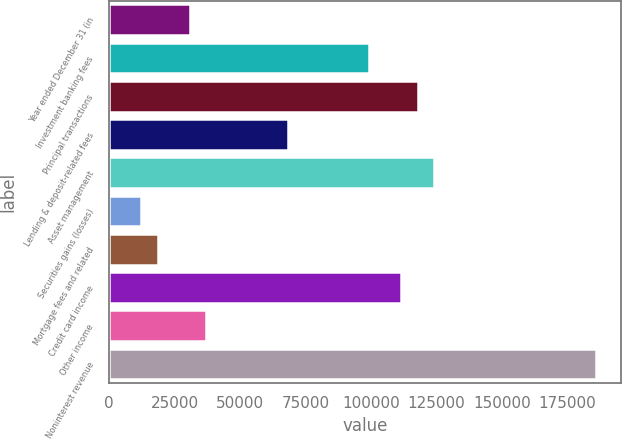<chart> <loc_0><loc_0><loc_500><loc_500><bar_chart><fcel>Year ended December 31 (in<fcel>Investment banking fees<fcel>Principal transactions<fcel>Lending & deposit-related fees<fcel>Asset management<fcel>Securities gains (losses)<fcel>Mortgage fees and related<fcel>Credit card income<fcel>Other income<fcel>Noninterest revenue<nl><fcel>31000.2<fcel>99197.5<fcel>117797<fcel>68198.7<fcel>123997<fcel>12400.9<fcel>18600.6<fcel>111597<fcel>37199.9<fcel>185994<nl></chart> 